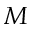<formula> <loc_0><loc_0><loc_500><loc_500>M</formula> 